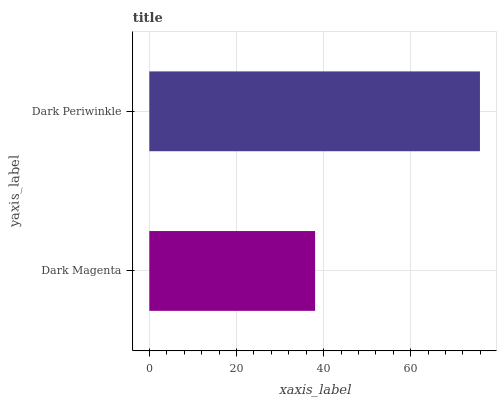Is Dark Magenta the minimum?
Answer yes or no. Yes. Is Dark Periwinkle the maximum?
Answer yes or no. Yes. Is Dark Periwinkle the minimum?
Answer yes or no. No. Is Dark Periwinkle greater than Dark Magenta?
Answer yes or no. Yes. Is Dark Magenta less than Dark Periwinkle?
Answer yes or no. Yes. Is Dark Magenta greater than Dark Periwinkle?
Answer yes or no. No. Is Dark Periwinkle less than Dark Magenta?
Answer yes or no. No. Is Dark Periwinkle the high median?
Answer yes or no. Yes. Is Dark Magenta the low median?
Answer yes or no. Yes. Is Dark Magenta the high median?
Answer yes or no. No. Is Dark Periwinkle the low median?
Answer yes or no. No. 